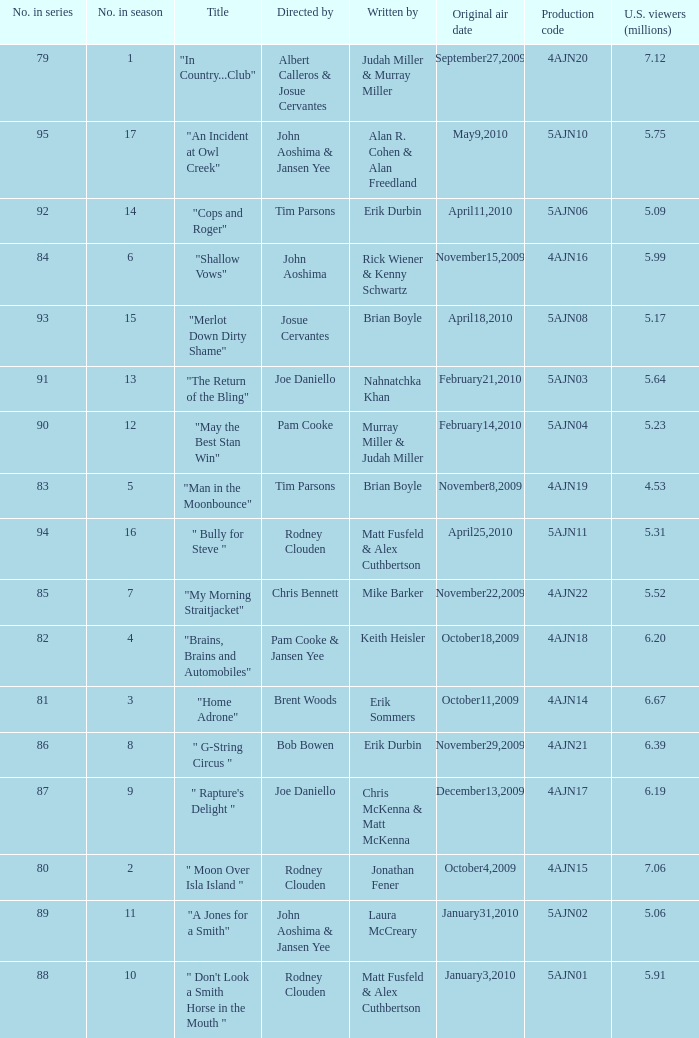Name the original air date for " don't look a smith horse in the mouth " January3,2010. 